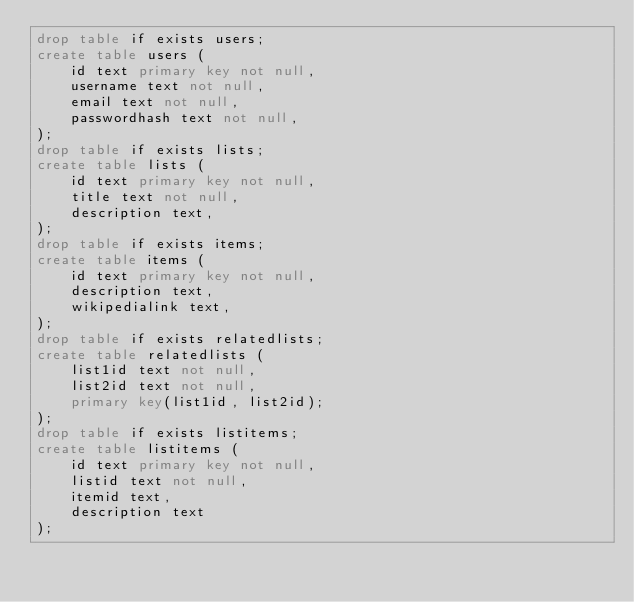Convert code to text. <code><loc_0><loc_0><loc_500><loc_500><_SQL_>drop table if exists users;
create table users (
    id text primary key not null,
    username text not null,
    email text not null,
    passwordhash text not null,
);
drop table if exists lists;
create table lists (
    id text primary key not null,
    title text not null,
    description text,
);
drop table if exists items;
create table items (
    id text primary key not null,
    description text,
    wikipedialink text,
);
drop table if exists relatedlists;
create table relatedlists (
    list1id text not null,
    list2id text not null,
    primary key(list1id, list2id);
);
drop table if exists listitems;
create table listitems (
    id text primary key not null,
    listid text not null,
    itemid text,
    description text
);
</code> 